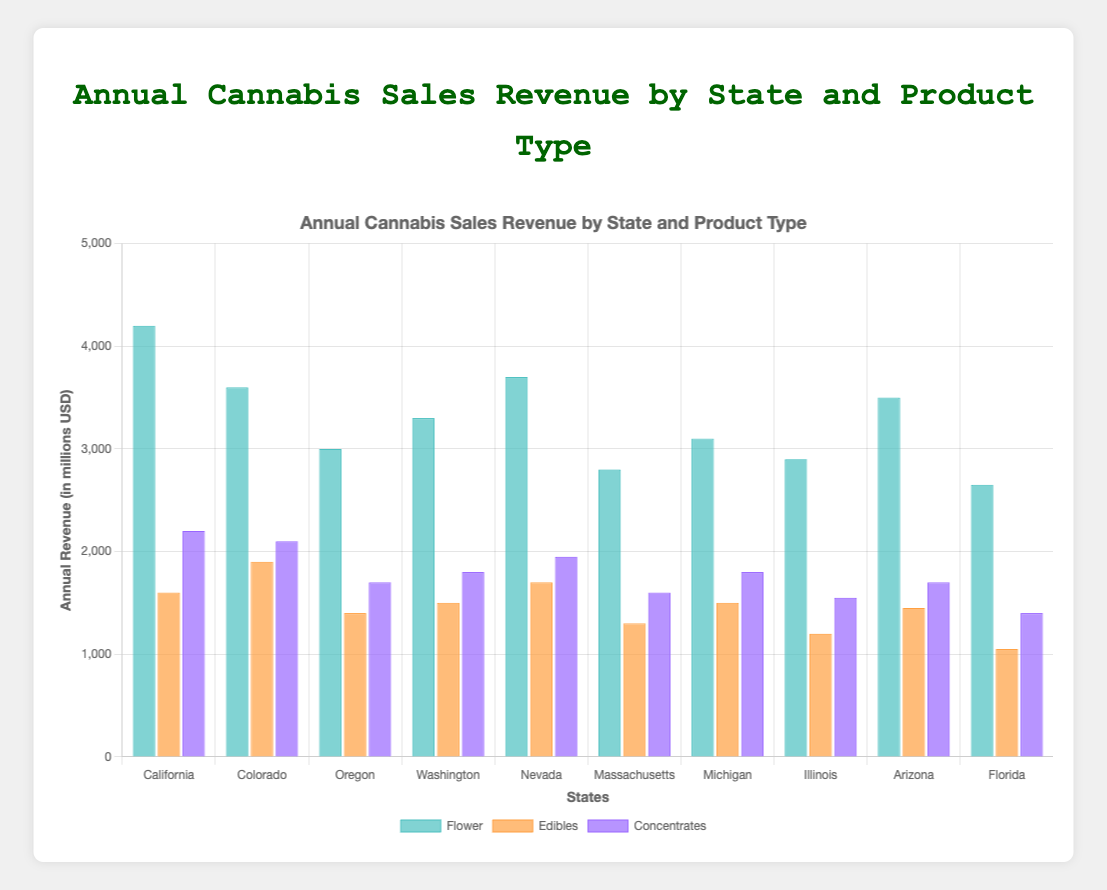Which state has the highest annual revenue from flower sales? By checking the height of the bars representing flower sales for each state, California has the tallest bar.
Answer: California Which product category has the highest total revenue across all states? Sum the revenues for each product (flower, edibles, concentrates) across all states. Flower: 4200+3600+3000+3300+3700+2800+3100+2900+3500+2650 = 32750, Edibles: 1600+1900+1400+1500+1700+1300+1500+1200+1450+1050 = 14600, Concentrates: 2200+2100+1700+1800+1950+1600+1800+1550+1700+1400 = 17800. Flower has the highest total revenue.
Answer: Flower What is the difference in annual revenue from edibles between Colorado and Massachusetts? Check the bars representing edibles for Colorado and Massachusetts, then subtract the smaller value from the larger. 1900 (Colorado) - 1300 (Massachusetts) = 600
Answer: 600 Which state has the lowest revenue from concentrates? By comparing the height of the bars representing concentrates, Florida has the shortest bar.
Answer: Florida How does the revenue from flower sales in Arizona compare to that in Florida? Compare the heights of the bars for flower sales in Arizona and Florida. Arizona (3500) has a taller bar than Florida (2650), so Arizona has higher revenue.
Answer: Arizona What is the total revenue from edibles in the Western states (California, Oregon, Washington, Nevada, Arizona)? Sum the revenues from edibles for California, Oregon, Washington, Nevada, and Arizona: 1600 + 1400 + 1500 + 1700 + 1450 = 7650
Answer: 7650 Which product type generates the least revenue in Nevada? Compare the heights of the three bars for Nevada. Edibles (1700) have the shortest bar.
Answer: Edibles How much more revenue does California generate from flower sales compared to Oregon? Subtract the flower revenue for Oregon from that for California: 4200 - 3000 = 1200
Answer: 1200 What is the average revenue from concentrates across all states? sum the concentrate revenues and divide by the number of states: (2200+2100+1700+1800+1950+1600+1800+1550+1700+1400) / 10 = 17800 / 10 = 1780
Answer: 1780 Does Michigan generate more revenue from edibles or concentrates? Compare the heights of the bars for edibles and concentrates in Michigan. Both revenue bars are the same height at 1500 and 1800 respectively.
Answer: Concentrates 